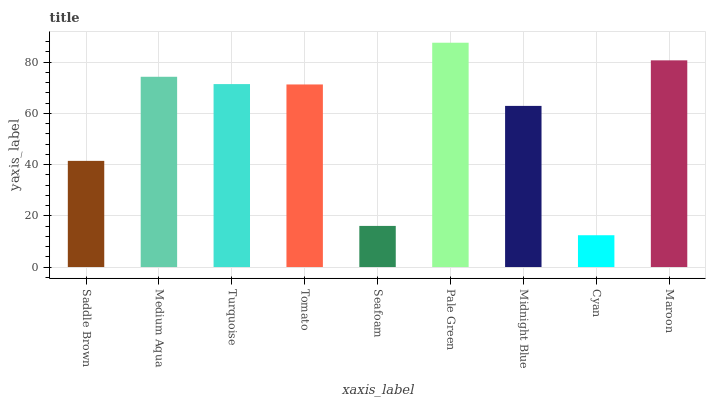Is Cyan the minimum?
Answer yes or no. Yes. Is Pale Green the maximum?
Answer yes or no. Yes. Is Medium Aqua the minimum?
Answer yes or no. No. Is Medium Aqua the maximum?
Answer yes or no. No. Is Medium Aqua greater than Saddle Brown?
Answer yes or no. Yes. Is Saddle Brown less than Medium Aqua?
Answer yes or no. Yes. Is Saddle Brown greater than Medium Aqua?
Answer yes or no. No. Is Medium Aqua less than Saddle Brown?
Answer yes or no. No. Is Tomato the high median?
Answer yes or no. Yes. Is Tomato the low median?
Answer yes or no. Yes. Is Cyan the high median?
Answer yes or no. No. Is Maroon the low median?
Answer yes or no. No. 